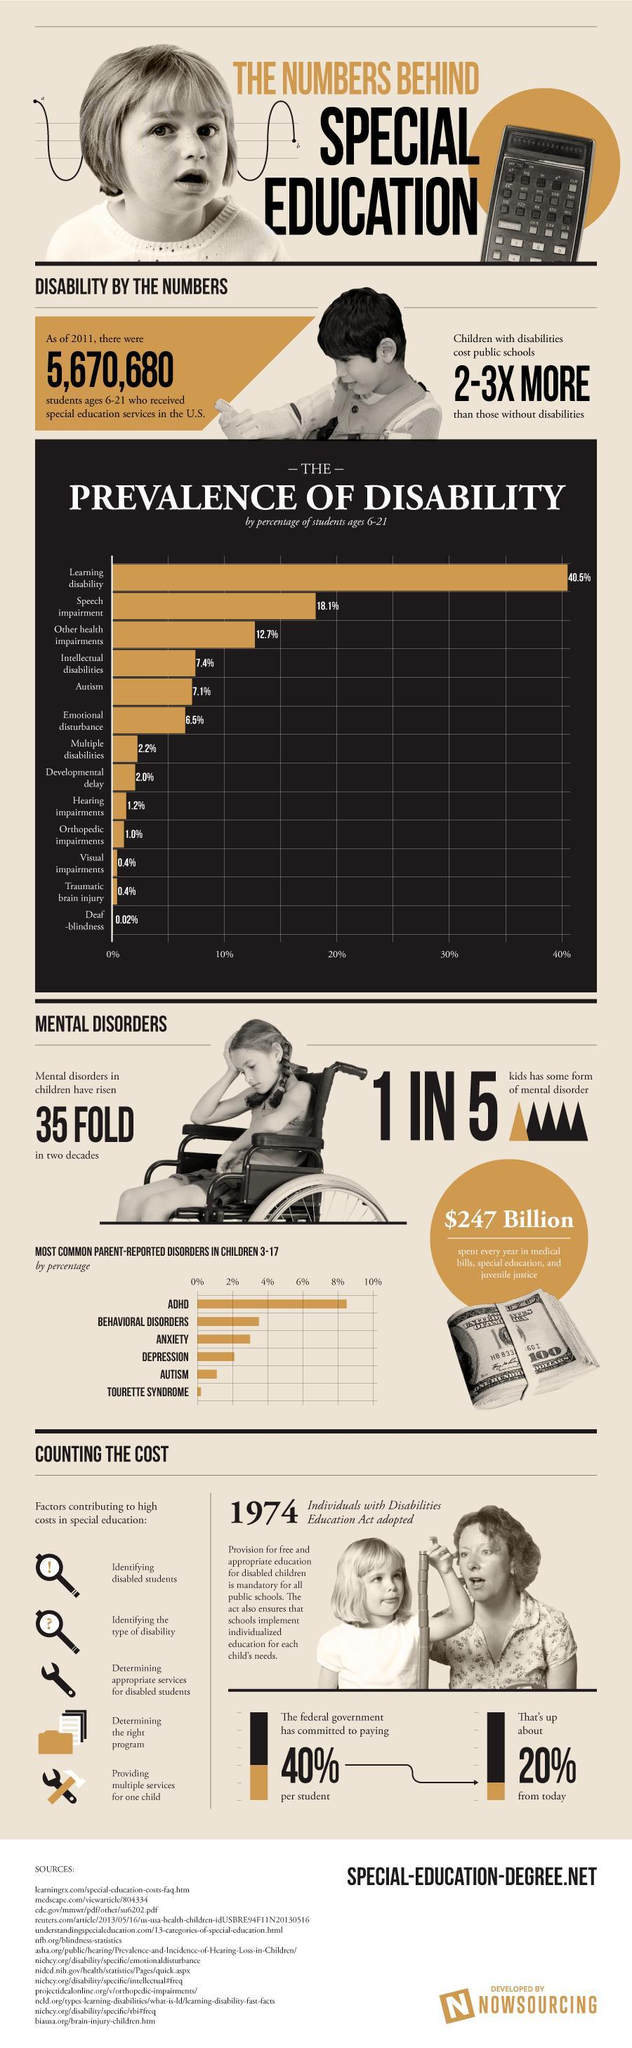How many parent-reported disorders mentioned in this infographic?
Answer the question with a short phrase. 6 What is the number of disabilities whose prevalence of disability by percentage is greater than 18%? 2 How many disabilities whose prevalence of disability by percentage is between 7 and 7.5? 2 Out of 5, how many kids have no mental disorder? 4 